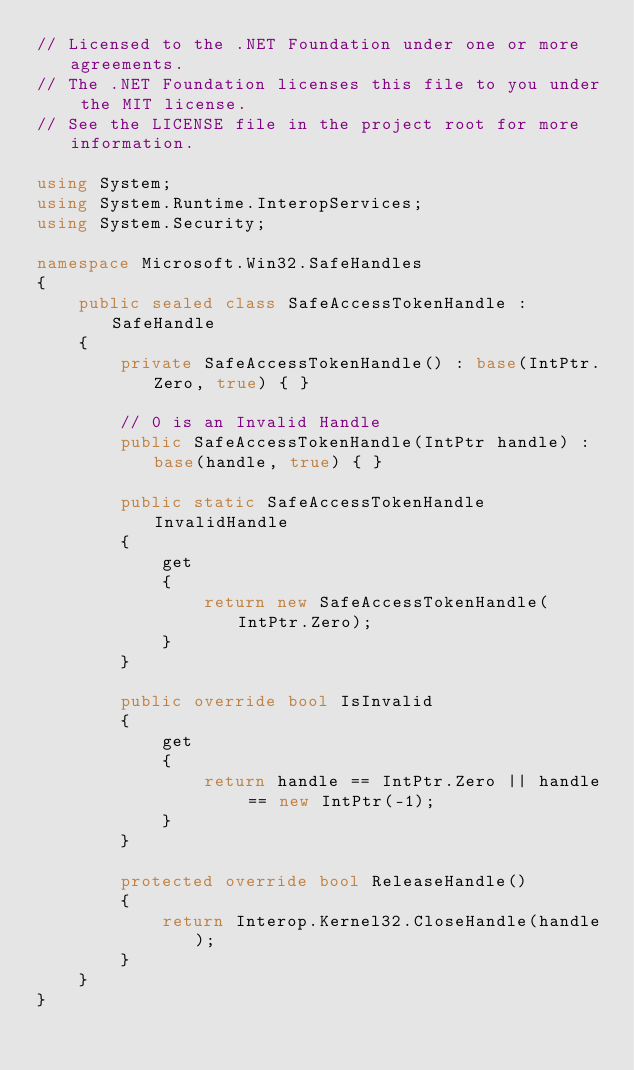Convert code to text. <code><loc_0><loc_0><loc_500><loc_500><_C#_>// Licensed to the .NET Foundation under one or more agreements.
// The .NET Foundation licenses this file to you under the MIT license.
// See the LICENSE file in the project root for more information.

using System;
using System.Runtime.InteropServices;
using System.Security;

namespace Microsoft.Win32.SafeHandles
{
    public sealed class SafeAccessTokenHandle : SafeHandle
    {
        private SafeAccessTokenHandle() : base(IntPtr.Zero, true) { }

        // 0 is an Invalid Handle
        public SafeAccessTokenHandle(IntPtr handle) : base(handle, true) { }

        public static SafeAccessTokenHandle InvalidHandle
        {
            get
            {
                return new SafeAccessTokenHandle(IntPtr.Zero);
            }
        }

        public override bool IsInvalid
        {
            get
            {
                return handle == IntPtr.Zero || handle == new IntPtr(-1);
            }
        }

        protected override bool ReleaseHandle()
        {
            return Interop.Kernel32.CloseHandle(handle);
        }
    }
}
</code> 